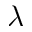Convert formula to latex. <formula><loc_0><loc_0><loc_500><loc_500>\lambda</formula> 